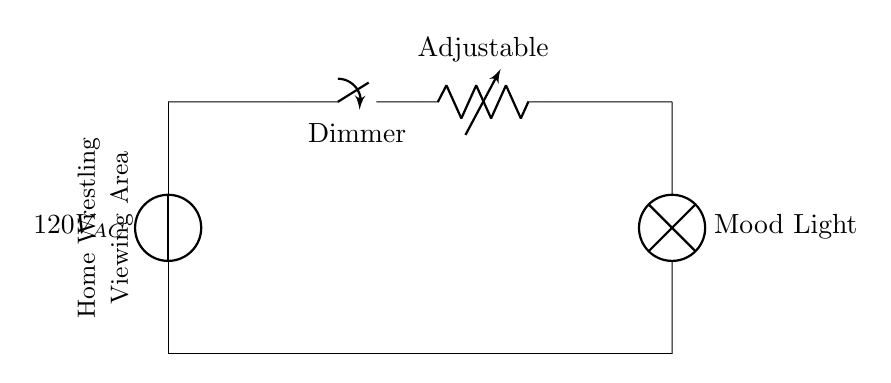What is the voltage of this circuit? The circuit operates at an AC voltage of 120 volts. This is indicated by the voltage source labeled as 120V AC at the beginning of the circuit diagram.
Answer: 120 volts What component controls the brightness of the light? The dimmer switch is what allows for the adjustment of the light's brightness. It is marked as a closing switch in the circuit diagram, which can change its resistance to control the current flowing through to the lamp.
Answer: Dimmer switch What type of light is used in this circuit? The circuit diagram includes a lamp labeled 'Mood Light'. This indicates the type of light being used to create an ambiance in the viewing area.
Answer: Mood Light How many main components are in this circuit? The main components visible in the circuit include the voltage source, the dimmer switch, the variable resistor, and the lamp, totaling four key elements. This is identifiable by counting the distinct electrical components shown in the diagram.
Answer: Four What effect does increasing the variable resistor have on the mood light? Increasing the variable resistor will increase its resistance, leading to a decrease in current flowing to the mood light. This will cause the bulb to dim as less power is delivered to it. The relationship between resistance, current, and power dynamics explains this behavior in an electrical circuit.
Answer: Dims the light What is the purpose of the adjustable resistor in this circuit? The adjustable resistor allows variable control over the amount of current that flows to the lamp. By changing its resistance, users can fine-tune the brightness level of the mood light according to their preference in the wrestling viewing area.
Answer: Brightness control 